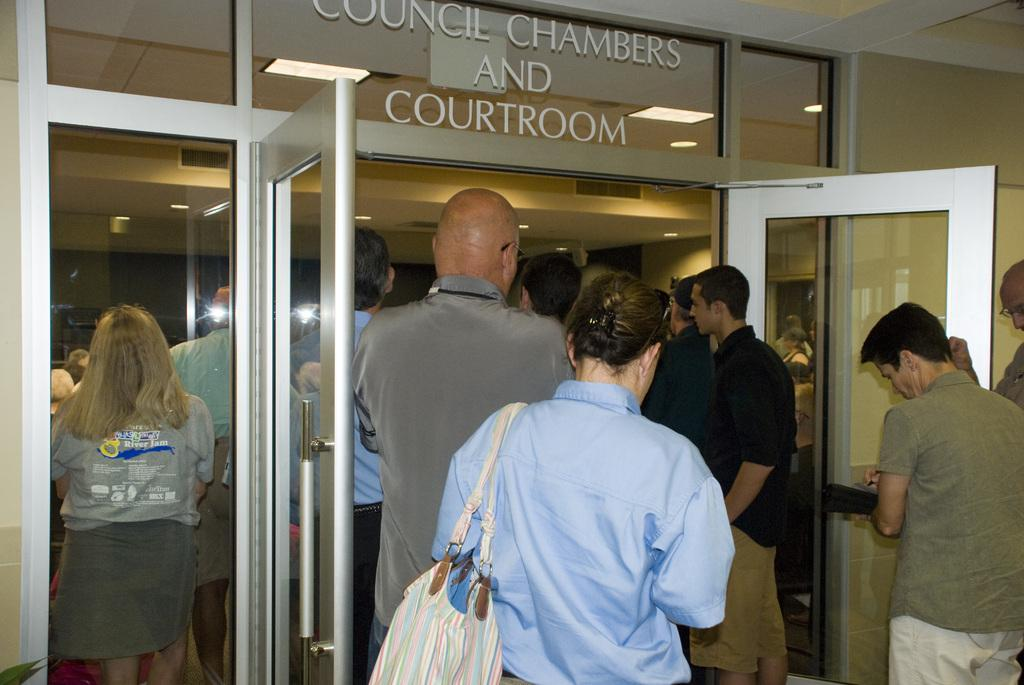What is the setting of the image? The image shows the inside view of a room. What can be seen in the room? There are people standing in the room, and a person is carrying a bag. What is a feature of the room that provides access to other areas? There is a door in the room. What helps to illuminate the room? There are lights in the room. What type of pen is being used by the person in the image? There is no pen present in the image. What kind of doll is sitting on the table in the image? There is no doll present in the image. 